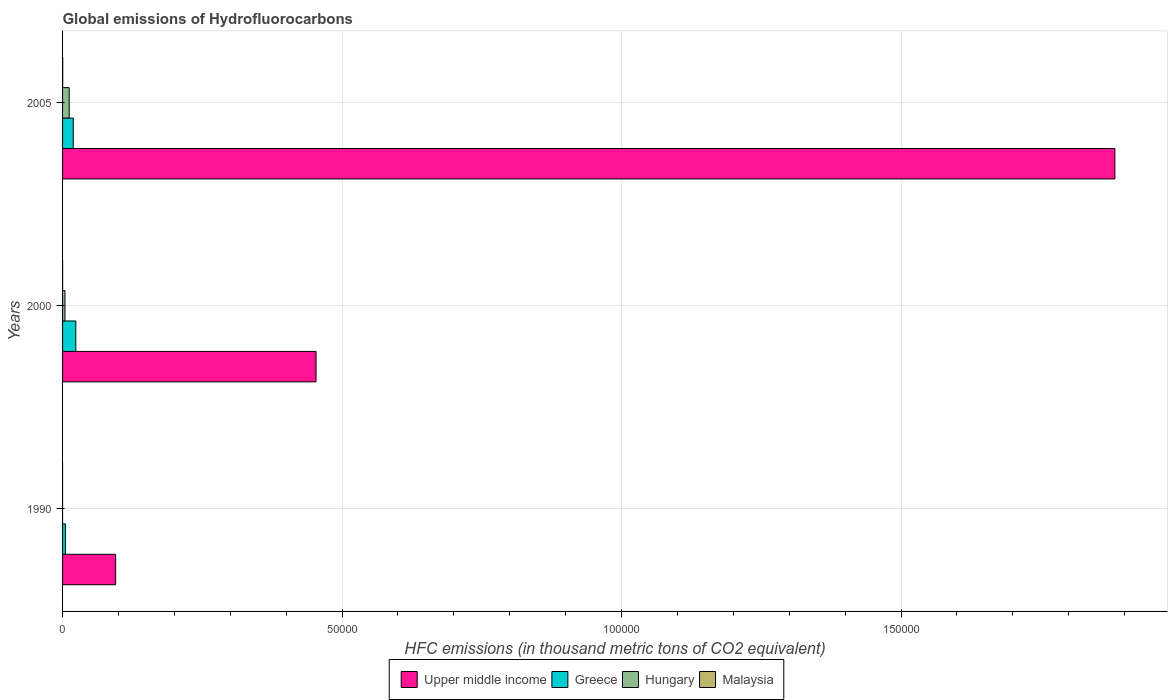How many different coloured bars are there?
Your answer should be very brief. 4. How many groups of bars are there?
Offer a very short reply. 3. Are the number of bars on each tick of the Y-axis equal?
Ensure brevity in your answer.  Yes. How many bars are there on the 1st tick from the top?
Offer a terse response. 4. How many bars are there on the 2nd tick from the bottom?
Your answer should be very brief. 4. In how many cases, is the number of bars for a given year not equal to the number of legend labels?
Offer a very short reply. 0. What is the global emissions of Hydrofluorocarbons in Upper middle income in 2000?
Provide a short and direct response. 4.53e+04. Across all years, what is the maximum global emissions of Hydrofluorocarbons in Hungary?
Your response must be concise. 1191.4. Across all years, what is the minimum global emissions of Hydrofluorocarbons in Malaysia?
Offer a terse response. 0.1. In which year was the global emissions of Hydrofluorocarbons in Malaysia maximum?
Ensure brevity in your answer.  2005. What is the total global emissions of Hydrofluorocarbons in Upper middle income in the graph?
Your answer should be compact. 2.43e+05. What is the difference between the global emissions of Hydrofluorocarbons in Upper middle income in 2000 and that in 2005?
Give a very brief answer. -1.43e+05. What is the difference between the global emissions of Hydrofluorocarbons in Hungary in 1990 and the global emissions of Hydrofluorocarbons in Upper middle income in 2000?
Offer a very short reply. -4.53e+04. What is the average global emissions of Hydrofluorocarbons in Hungary per year?
Offer a terse response. 539.9. In the year 1990, what is the difference between the global emissions of Hydrofluorocarbons in Upper middle income and global emissions of Hydrofluorocarbons in Malaysia?
Offer a very short reply. 9496.8. In how many years, is the global emissions of Hydrofluorocarbons in Malaysia greater than 40000 thousand metric tons?
Ensure brevity in your answer.  0. What is the ratio of the global emissions of Hydrofluorocarbons in Hungary in 1990 to that in 2005?
Provide a succinct answer. 8.393486654356219e-5. Is the difference between the global emissions of Hydrofluorocarbons in Upper middle income in 2000 and 2005 greater than the difference between the global emissions of Hydrofluorocarbons in Malaysia in 2000 and 2005?
Your response must be concise. No. What is the difference between the highest and the second highest global emissions of Hydrofluorocarbons in Greece?
Make the answer very short. 457. What is the difference between the highest and the lowest global emissions of Hydrofluorocarbons in Upper middle income?
Provide a succinct answer. 1.79e+05. In how many years, is the global emissions of Hydrofluorocarbons in Upper middle income greater than the average global emissions of Hydrofluorocarbons in Upper middle income taken over all years?
Keep it short and to the point. 1. Is the sum of the global emissions of Hydrofluorocarbons in Hungary in 1990 and 2000 greater than the maximum global emissions of Hydrofluorocarbons in Malaysia across all years?
Keep it short and to the point. Yes. What does the 1st bar from the top in 2000 represents?
Ensure brevity in your answer.  Malaysia. What does the 3rd bar from the bottom in 2005 represents?
Ensure brevity in your answer.  Hungary. Is it the case that in every year, the sum of the global emissions of Hydrofluorocarbons in Malaysia and global emissions of Hydrofluorocarbons in Greece is greater than the global emissions of Hydrofluorocarbons in Hungary?
Give a very brief answer. Yes. Are all the bars in the graph horizontal?
Your response must be concise. Yes. What is the difference between two consecutive major ticks on the X-axis?
Your answer should be compact. 5.00e+04. Does the graph contain any zero values?
Offer a very short reply. No. Does the graph contain grids?
Offer a very short reply. Yes. What is the title of the graph?
Your answer should be very brief. Global emissions of Hydrofluorocarbons. What is the label or title of the X-axis?
Your answer should be very brief. HFC emissions (in thousand metric tons of CO2 equivalent). What is the label or title of the Y-axis?
Your answer should be very brief. Years. What is the HFC emissions (in thousand metric tons of CO2 equivalent) of Upper middle income in 1990?
Make the answer very short. 9496.9. What is the HFC emissions (in thousand metric tons of CO2 equivalent) of Greece in 1990?
Your response must be concise. 507.2. What is the HFC emissions (in thousand metric tons of CO2 equivalent) of Upper middle income in 2000?
Your answer should be compact. 4.53e+04. What is the HFC emissions (in thousand metric tons of CO2 equivalent) of Greece in 2000?
Make the answer very short. 2368.4. What is the HFC emissions (in thousand metric tons of CO2 equivalent) of Hungary in 2000?
Offer a terse response. 428.2. What is the HFC emissions (in thousand metric tons of CO2 equivalent) of Malaysia in 2000?
Your response must be concise. 6.9. What is the HFC emissions (in thousand metric tons of CO2 equivalent) in Upper middle income in 2005?
Provide a succinct answer. 1.88e+05. What is the HFC emissions (in thousand metric tons of CO2 equivalent) in Greece in 2005?
Provide a succinct answer. 1911.4. What is the HFC emissions (in thousand metric tons of CO2 equivalent) of Hungary in 2005?
Your answer should be very brief. 1191.4. What is the HFC emissions (in thousand metric tons of CO2 equivalent) of Malaysia in 2005?
Your answer should be compact. 26.1. Across all years, what is the maximum HFC emissions (in thousand metric tons of CO2 equivalent) in Upper middle income?
Give a very brief answer. 1.88e+05. Across all years, what is the maximum HFC emissions (in thousand metric tons of CO2 equivalent) in Greece?
Offer a very short reply. 2368.4. Across all years, what is the maximum HFC emissions (in thousand metric tons of CO2 equivalent) in Hungary?
Your answer should be compact. 1191.4. Across all years, what is the maximum HFC emissions (in thousand metric tons of CO2 equivalent) in Malaysia?
Your response must be concise. 26.1. Across all years, what is the minimum HFC emissions (in thousand metric tons of CO2 equivalent) of Upper middle income?
Give a very brief answer. 9496.9. Across all years, what is the minimum HFC emissions (in thousand metric tons of CO2 equivalent) in Greece?
Provide a succinct answer. 507.2. What is the total HFC emissions (in thousand metric tons of CO2 equivalent) of Upper middle income in the graph?
Give a very brief answer. 2.43e+05. What is the total HFC emissions (in thousand metric tons of CO2 equivalent) of Greece in the graph?
Give a very brief answer. 4787. What is the total HFC emissions (in thousand metric tons of CO2 equivalent) of Hungary in the graph?
Offer a terse response. 1619.7. What is the total HFC emissions (in thousand metric tons of CO2 equivalent) of Malaysia in the graph?
Provide a short and direct response. 33.1. What is the difference between the HFC emissions (in thousand metric tons of CO2 equivalent) in Upper middle income in 1990 and that in 2000?
Make the answer very short. -3.58e+04. What is the difference between the HFC emissions (in thousand metric tons of CO2 equivalent) in Greece in 1990 and that in 2000?
Keep it short and to the point. -1861.2. What is the difference between the HFC emissions (in thousand metric tons of CO2 equivalent) in Hungary in 1990 and that in 2000?
Ensure brevity in your answer.  -428.1. What is the difference between the HFC emissions (in thousand metric tons of CO2 equivalent) of Malaysia in 1990 and that in 2000?
Keep it short and to the point. -6.8. What is the difference between the HFC emissions (in thousand metric tons of CO2 equivalent) of Upper middle income in 1990 and that in 2005?
Your answer should be very brief. -1.79e+05. What is the difference between the HFC emissions (in thousand metric tons of CO2 equivalent) in Greece in 1990 and that in 2005?
Give a very brief answer. -1404.2. What is the difference between the HFC emissions (in thousand metric tons of CO2 equivalent) of Hungary in 1990 and that in 2005?
Make the answer very short. -1191.3. What is the difference between the HFC emissions (in thousand metric tons of CO2 equivalent) in Upper middle income in 2000 and that in 2005?
Offer a terse response. -1.43e+05. What is the difference between the HFC emissions (in thousand metric tons of CO2 equivalent) of Greece in 2000 and that in 2005?
Your answer should be compact. 457. What is the difference between the HFC emissions (in thousand metric tons of CO2 equivalent) in Hungary in 2000 and that in 2005?
Provide a short and direct response. -763.2. What is the difference between the HFC emissions (in thousand metric tons of CO2 equivalent) of Malaysia in 2000 and that in 2005?
Your answer should be very brief. -19.2. What is the difference between the HFC emissions (in thousand metric tons of CO2 equivalent) of Upper middle income in 1990 and the HFC emissions (in thousand metric tons of CO2 equivalent) of Greece in 2000?
Give a very brief answer. 7128.5. What is the difference between the HFC emissions (in thousand metric tons of CO2 equivalent) in Upper middle income in 1990 and the HFC emissions (in thousand metric tons of CO2 equivalent) in Hungary in 2000?
Provide a short and direct response. 9068.7. What is the difference between the HFC emissions (in thousand metric tons of CO2 equivalent) in Upper middle income in 1990 and the HFC emissions (in thousand metric tons of CO2 equivalent) in Malaysia in 2000?
Offer a very short reply. 9490. What is the difference between the HFC emissions (in thousand metric tons of CO2 equivalent) in Greece in 1990 and the HFC emissions (in thousand metric tons of CO2 equivalent) in Hungary in 2000?
Offer a terse response. 79. What is the difference between the HFC emissions (in thousand metric tons of CO2 equivalent) of Greece in 1990 and the HFC emissions (in thousand metric tons of CO2 equivalent) of Malaysia in 2000?
Your answer should be very brief. 500.3. What is the difference between the HFC emissions (in thousand metric tons of CO2 equivalent) in Upper middle income in 1990 and the HFC emissions (in thousand metric tons of CO2 equivalent) in Greece in 2005?
Keep it short and to the point. 7585.5. What is the difference between the HFC emissions (in thousand metric tons of CO2 equivalent) in Upper middle income in 1990 and the HFC emissions (in thousand metric tons of CO2 equivalent) in Hungary in 2005?
Your answer should be very brief. 8305.5. What is the difference between the HFC emissions (in thousand metric tons of CO2 equivalent) in Upper middle income in 1990 and the HFC emissions (in thousand metric tons of CO2 equivalent) in Malaysia in 2005?
Provide a succinct answer. 9470.8. What is the difference between the HFC emissions (in thousand metric tons of CO2 equivalent) in Greece in 1990 and the HFC emissions (in thousand metric tons of CO2 equivalent) in Hungary in 2005?
Ensure brevity in your answer.  -684.2. What is the difference between the HFC emissions (in thousand metric tons of CO2 equivalent) in Greece in 1990 and the HFC emissions (in thousand metric tons of CO2 equivalent) in Malaysia in 2005?
Provide a short and direct response. 481.1. What is the difference between the HFC emissions (in thousand metric tons of CO2 equivalent) of Upper middle income in 2000 and the HFC emissions (in thousand metric tons of CO2 equivalent) of Greece in 2005?
Your answer should be very brief. 4.34e+04. What is the difference between the HFC emissions (in thousand metric tons of CO2 equivalent) of Upper middle income in 2000 and the HFC emissions (in thousand metric tons of CO2 equivalent) of Hungary in 2005?
Provide a succinct answer. 4.42e+04. What is the difference between the HFC emissions (in thousand metric tons of CO2 equivalent) of Upper middle income in 2000 and the HFC emissions (in thousand metric tons of CO2 equivalent) of Malaysia in 2005?
Your response must be concise. 4.53e+04. What is the difference between the HFC emissions (in thousand metric tons of CO2 equivalent) in Greece in 2000 and the HFC emissions (in thousand metric tons of CO2 equivalent) in Hungary in 2005?
Give a very brief answer. 1177. What is the difference between the HFC emissions (in thousand metric tons of CO2 equivalent) of Greece in 2000 and the HFC emissions (in thousand metric tons of CO2 equivalent) of Malaysia in 2005?
Offer a terse response. 2342.3. What is the difference between the HFC emissions (in thousand metric tons of CO2 equivalent) in Hungary in 2000 and the HFC emissions (in thousand metric tons of CO2 equivalent) in Malaysia in 2005?
Offer a very short reply. 402.1. What is the average HFC emissions (in thousand metric tons of CO2 equivalent) of Upper middle income per year?
Offer a terse response. 8.10e+04. What is the average HFC emissions (in thousand metric tons of CO2 equivalent) of Greece per year?
Your answer should be very brief. 1595.67. What is the average HFC emissions (in thousand metric tons of CO2 equivalent) in Hungary per year?
Ensure brevity in your answer.  539.9. What is the average HFC emissions (in thousand metric tons of CO2 equivalent) in Malaysia per year?
Your answer should be compact. 11.03. In the year 1990, what is the difference between the HFC emissions (in thousand metric tons of CO2 equivalent) in Upper middle income and HFC emissions (in thousand metric tons of CO2 equivalent) in Greece?
Ensure brevity in your answer.  8989.7. In the year 1990, what is the difference between the HFC emissions (in thousand metric tons of CO2 equivalent) of Upper middle income and HFC emissions (in thousand metric tons of CO2 equivalent) of Hungary?
Your answer should be compact. 9496.8. In the year 1990, what is the difference between the HFC emissions (in thousand metric tons of CO2 equivalent) of Upper middle income and HFC emissions (in thousand metric tons of CO2 equivalent) of Malaysia?
Give a very brief answer. 9496.8. In the year 1990, what is the difference between the HFC emissions (in thousand metric tons of CO2 equivalent) of Greece and HFC emissions (in thousand metric tons of CO2 equivalent) of Hungary?
Offer a very short reply. 507.1. In the year 1990, what is the difference between the HFC emissions (in thousand metric tons of CO2 equivalent) of Greece and HFC emissions (in thousand metric tons of CO2 equivalent) of Malaysia?
Your response must be concise. 507.1. In the year 1990, what is the difference between the HFC emissions (in thousand metric tons of CO2 equivalent) of Hungary and HFC emissions (in thousand metric tons of CO2 equivalent) of Malaysia?
Provide a succinct answer. 0. In the year 2000, what is the difference between the HFC emissions (in thousand metric tons of CO2 equivalent) of Upper middle income and HFC emissions (in thousand metric tons of CO2 equivalent) of Greece?
Offer a very short reply. 4.30e+04. In the year 2000, what is the difference between the HFC emissions (in thousand metric tons of CO2 equivalent) in Upper middle income and HFC emissions (in thousand metric tons of CO2 equivalent) in Hungary?
Make the answer very short. 4.49e+04. In the year 2000, what is the difference between the HFC emissions (in thousand metric tons of CO2 equivalent) in Upper middle income and HFC emissions (in thousand metric tons of CO2 equivalent) in Malaysia?
Offer a terse response. 4.53e+04. In the year 2000, what is the difference between the HFC emissions (in thousand metric tons of CO2 equivalent) of Greece and HFC emissions (in thousand metric tons of CO2 equivalent) of Hungary?
Offer a terse response. 1940.2. In the year 2000, what is the difference between the HFC emissions (in thousand metric tons of CO2 equivalent) of Greece and HFC emissions (in thousand metric tons of CO2 equivalent) of Malaysia?
Your answer should be compact. 2361.5. In the year 2000, what is the difference between the HFC emissions (in thousand metric tons of CO2 equivalent) in Hungary and HFC emissions (in thousand metric tons of CO2 equivalent) in Malaysia?
Offer a terse response. 421.3. In the year 2005, what is the difference between the HFC emissions (in thousand metric tons of CO2 equivalent) of Upper middle income and HFC emissions (in thousand metric tons of CO2 equivalent) of Greece?
Your answer should be compact. 1.86e+05. In the year 2005, what is the difference between the HFC emissions (in thousand metric tons of CO2 equivalent) of Upper middle income and HFC emissions (in thousand metric tons of CO2 equivalent) of Hungary?
Provide a short and direct response. 1.87e+05. In the year 2005, what is the difference between the HFC emissions (in thousand metric tons of CO2 equivalent) in Upper middle income and HFC emissions (in thousand metric tons of CO2 equivalent) in Malaysia?
Offer a terse response. 1.88e+05. In the year 2005, what is the difference between the HFC emissions (in thousand metric tons of CO2 equivalent) in Greece and HFC emissions (in thousand metric tons of CO2 equivalent) in Hungary?
Give a very brief answer. 720. In the year 2005, what is the difference between the HFC emissions (in thousand metric tons of CO2 equivalent) in Greece and HFC emissions (in thousand metric tons of CO2 equivalent) in Malaysia?
Offer a very short reply. 1885.3. In the year 2005, what is the difference between the HFC emissions (in thousand metric tons of CO2 equivalent) of Hungary and HFC emissions (in thousand metric tons of CO2 equivalent) of Malaysia?
Provide a succinct answer. 1165.3. What is the ratio of the HFC emissions (in thousand metric tons of CO2 equivalent) in Upper middle income in 1990 to that in 2000?
Provide a short and direct response. 0.21. What is the ratio of the HFC emissions (in thousand metric tons of CO2 equivalent) in Greece in 1990 to that in 2000?
Your answer should be very brief. 0.21. What is the ratio of the HFC emissions (in thousand metric tons of CO2 equivalent) in Malaysia in 1990 to that in 2000?
Offer a very short reply. 0.01. What is the ratio of the HFC emissions (in thousand metric tons of CO2 equivalent) in Upper middle income in 1990 to that in 2005?
Your answer should be very brief. 0.05. What is the ratio of the HFC emissions (in thousand metric tons of CO2 equivalent) of Greece in 1990 to that in 2005?
Provide a short and direct response. 0.27. What is the ratio of the HFC emissions (in thousand metric tons of CO2 equivalent) of Hungary in 1990 to that in 2005?
Make the answer very short. 0. What is the ratio of the HFC emissions (in thousand metric tons of CO2 equivalent) of Malaysia in 1990 to that in 2005?
Your answer should be compact. 0. What is the ratio of the HFC emissions (in thousand metric tons of CO2 equivalent) of Upper middle income in 2000 to that in 2005?
Give a very brief answer. 0.24. What is the ratio of the HFC emissions (in thousand metric tons of CO2 equivalent) of Greece in 2000 to that in 2005?
Make the answer very short. 1.24. What is the ratio of the HFC emissions (in thousand metric tons of CO2 equivalent) in Hungary in 2000 to that in 2005?
Keep it short and to the point. 0.36. What is the ratio of the HFC emissions (in thousand metric tons of CO2 equivalent) of Malaysia in 2000 to that in 2005?
Your response must be concise. 0.26. What is the difference between the highest and the second highest HFC emissions (in thousand metric tons of CO2 equivalent) in Upper middle income?
Your answer should be compact. 1.43e+05. What is the difference between the highest and the second highest HFC emissions (in thousand metric tons of CO2 equivalent) of Greece?
Keep it short and to the point. 457. What is the difference between the highest and the second highest HFC emissions (in thousand metric tons of CO2 equivalent) of Hungary?
Your response must be concise. 763.2. What is the difference between the highest and the second highest HFC emissions (in thousand metric tons of CO2 equivalent) in Malaysia?
Give a very brief answer. 19.2. What is the difference between the highest and the lowest HFC emissions (in thousand metric tons of CO2 equivalent) in Upper middle income?
Your answer should be compact. 1.79e+05. What is the difference between the highest and the lowest HFC emissions (in thousand metric tons of CO2 equivalent) of Greece?
Your response must be concise. 1861.2. What is the difference between the highest and the lowest HFC emissions (in thousand metric tons of CO2 equivalent) of Hungary?
Offer a very short reply. 1191.3. What is the difference between the highest and the lowest HFC emissions (in thousand metric tons of CO2 equivalent) of Malaysia?
Your response must be concise. 26. 